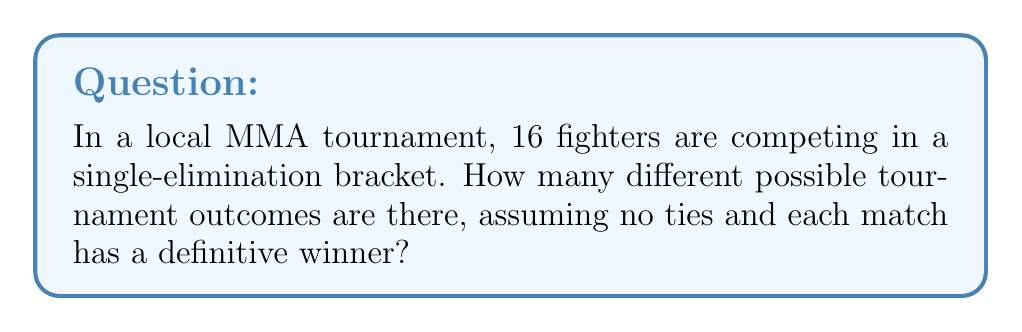What is the answer to this math problem? Let's approach this step-by-step:

1) In a single-elimination tournament with 16 fighters, there are 15 matches in total (8 in the first round, 4 in the second, 2 in the semifinals, and 1 in the final).

2) For each match, there are 2 possible outcomes (either fighter can win).

3) The number of possible outcomes for the entire tournament is the product of the number of possible outcomes for each match.

4) Therefore, the total number of possible outcomes is:

   $$2^{15}$$

5) To calculate this:
   
   $$2^{15} = 2 \times 2 \times 2 \times ... \times 2 \text{ (15 times)}$$

6) This can be computed as:

   $$2^{15} = 32,768$$

Thus, there are 32,768 different possible outcomes for the tournament.
Answer: $32,768$ 